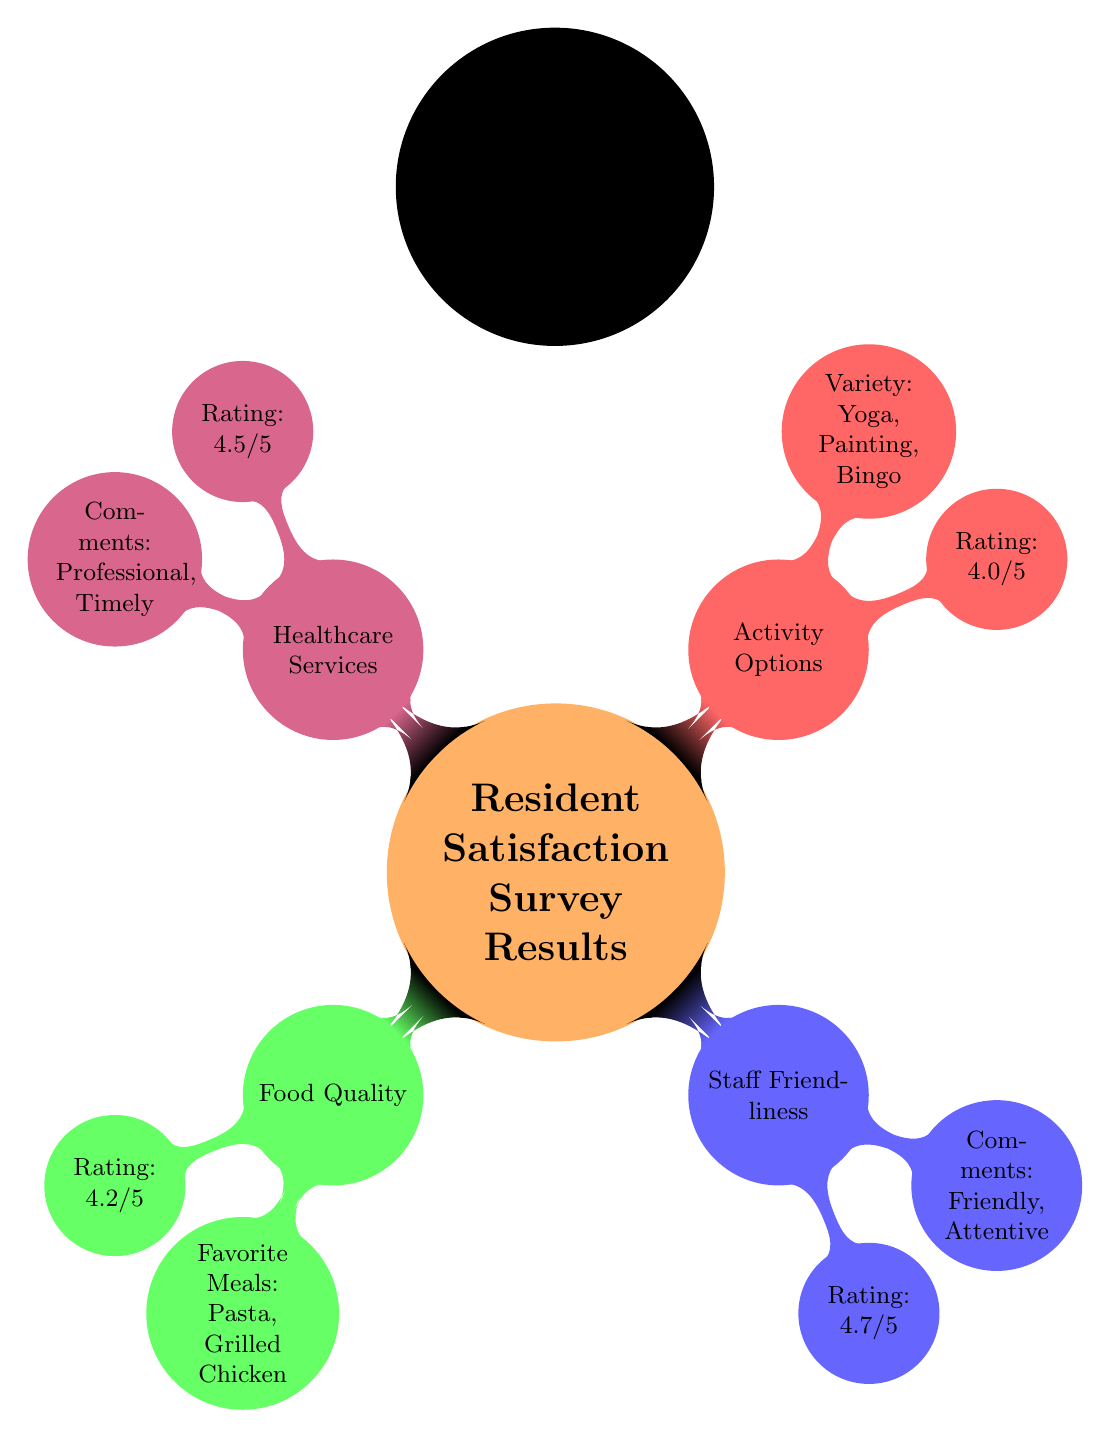What is the rating for food quality? The diagram explicitly states the rating for food quality. Under the node "Food Quality," it shows a "Rating: 4.2/5."
Answer: 4.2/5 What are the favorite meals according to resident feedback? The diagram lists the favorite meals under the "Food Quality" node. It mentions "Pasta" and "Grilled Chicken."
Answer: Pasta, Grilled Chicken Which area received the highest rating? To find the highest rating, we compare the ratings listed under each area: Food Quality (4.2), Staff Friendliness (4.7), Activity Options (4.0), and Healthcare Services (4.5). Clearly, the "Staff Friendliness" has the highest rating of 4.7.
Answer: Staff Friendliness What were the comments about healthcare services? The "Healthcare Services" node includes comments from resident feedback. It states "Professional, Timely," which summarizes resident opinions about these services.
Answer: Professional, Timely How many areas are covered in the survey results? The diagram presents four main areas categorized under the "Resident Satisfaction Survey Results": Food Quality, Staff Friendliness, Activity Options, and Healthcare Services. By counting these categories, we find there are four distinct areas.
Answer: 4 Which activity options are mentioned in the feedback? Under the "Activity Options" node, the diagram lists the specific options available. It mentions "Yoga, Painting, Bingo" as the activities residents have the option to participate in.
Answer: Yoga, Painting, Bingo What is the significance of the color scheme in the diagram? The color scheme differentiates between various categories in the diagram, where each area has a unique color: orange for the main node, green for Food Quality, blue for Staff Friendliness, red for Activity Options, and purple for Healthcare Services. This provides clarity and helps visually categorize the information presented.
Answer: Differentiation of categories Is there a category that has a rating below 4.0? In reviewing the ratings listed in the diagram, the ratings are: Food Quality (4.2), Staff Friendliness (4.7), Activity Options (4.0), and Healthcare Services (4.5). Since all ratings are at least 4.0 or higher, there doesn't exist a category below this threshold.
Answer: No What is the overall theme of the diagram? The overall theme of the diagram is to summarize the resident satisfaction survey results, focusing on different categories like food quality, staff friendliness, activity options, and healthcare services. These elements reflect the residents' experiences and suggestions, aimed at enhancing the quality of service.
Answer: Resident satisfaction survey results 